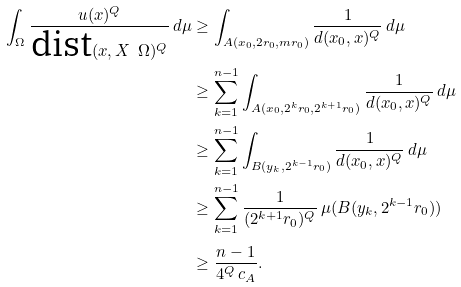Convert formula to latex. <formula><loc_0><loc_0><loc_500><loc_500>\int _ { \Omega } \frac { u ( x ) ^ { Q } } { \text {dist} ( x , X \ \Omega ) ^ { Q } } \, d \mu & \geq \int _ { A ( x _ { 0 } , 2 r _ { 0 } , m r _ { 0 } ) } \frac { 1 } { d ( x _ { 0 } , x ) ^ { Q } } \, d \mu \\ & \geq \sum _ { k = 1 } ^ { n - 1 } \int _ { A ( x _ { 0 } , 2 ^ { k } r _ { 0 } , 2 ^ { k + 1 } r _ { 0 } ) } \frac { 1 } { d ( x _ { 0 } , x ) ^ { Q } } \, d \mu \\ & \geq \sum _ { k = 1 } ^ { n - 1 } \int _ { B ( y _ { k } , 2 ^ { k - 1 } r _ { 0 } ) } \frac { 1 } { d ( x _ { 0 } , x ) ^ { Q } } \, d \mu \\ & \geq \sum _ { k = 1 } ^ { n - 1 } \frac { 1 } { ( 2 ^ { k + 1 } r _ { 0 } ) ^ { Q } } \, \mu ( B ( y _ { k } , 2 ^ { k - 1 } r _ { 0 } ) ) \\ & \geq \frac { n - 1 } { 4 ^ { Q } \, c _ { A } } .</formula> 